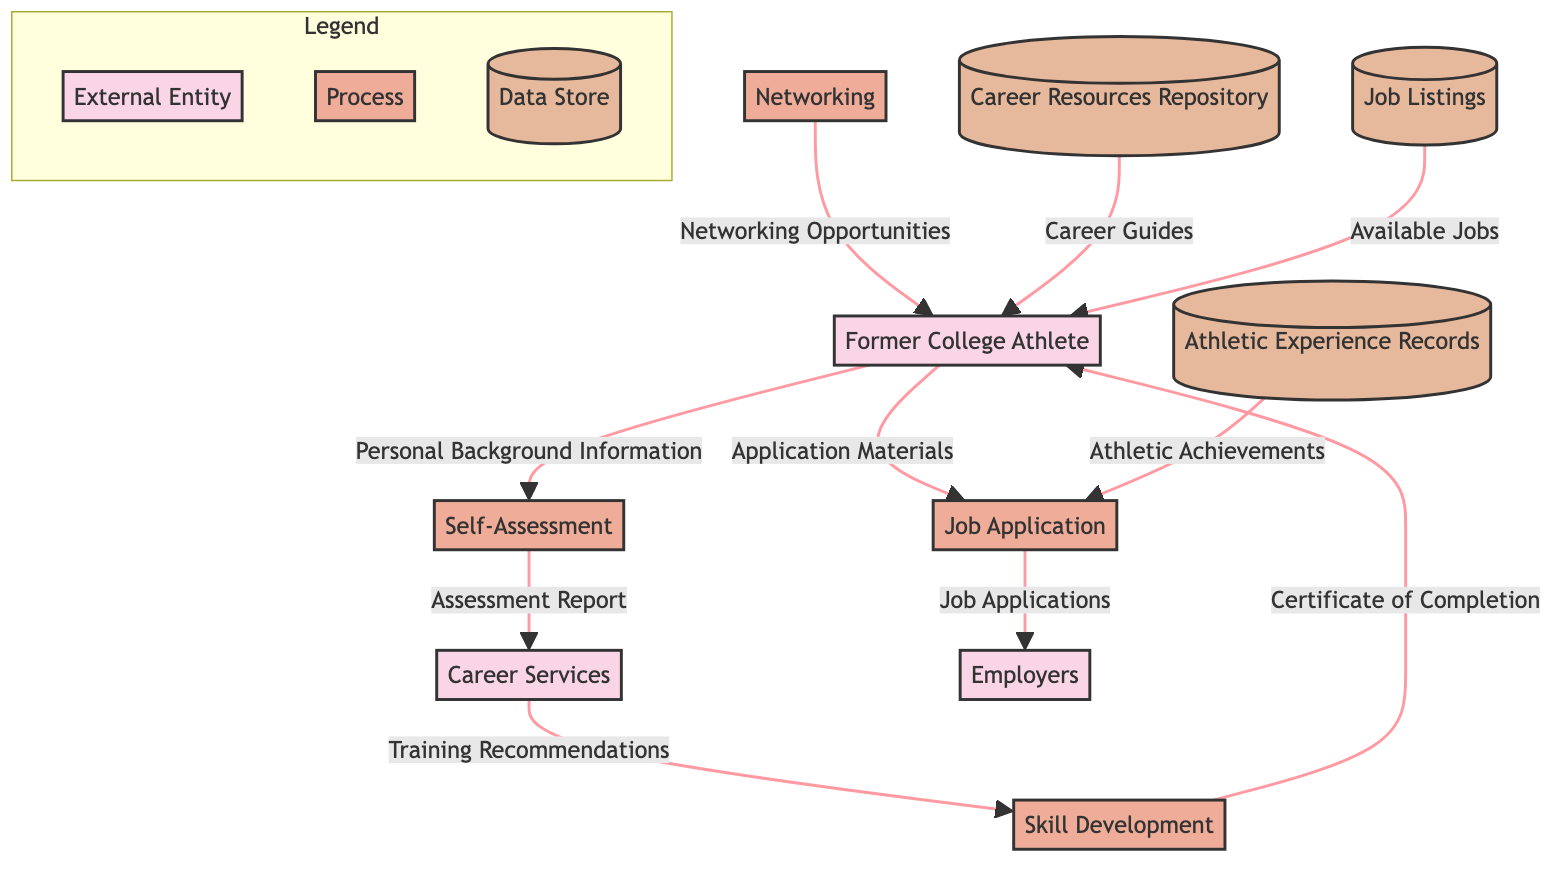What is the first process in the diagram? The first process listed in the processes section of the diagram is "Self-Assessment." This is determined by looking at the order of processes presented, starting with the top.
Answer: Self-Assessment How many external entities are present in the diagram? The diagram shows three external entities: Former College Athlete, Career Services, and Employers. Counting these nodes gives the total number of external entities.
Answer: 3 What data flows from Career Services to Skill Development? The data flowing from Career Services to Skill Development is "Training Recommendations." This is indicated by the arrow connecting these two nodes in the diagram.
Answer: Training Recommendations Which datastore provides career guides to the Former College Athlete? The "Career Resources Repository" provides career guides to the Former College Athlete, as indicated by the data flow that connects the repository to the athlete.
Answer: Career Resources Repository How many processes lead to the Former College Athlete? There are three processes that lead to the Former College Athlete: Skill Development, Networking, and Job Application. By examining the arrows pointing towards the athlete's node, we can confirm this count.
Answer: 3 What is the final process in the diagram before applications are sent to employers? The final process before applications are sent to employers is "Job Application." It's the last step before the data flow to Employers, as seen at the bottom of the diagram.
Answer: Job Application Which data store is linked to the process of Resume Preparation? "Athletic Experience Records" is linked to the process of Resume Preparation. Although Resume Preparation is not explicitly diagrammed as a node, the flow indicates that this store contributes to application materials.
Answer: Athletic Experience Records What type of data does the “Job Listings” datastore provide to the Former College Athlete? The "Job Listings" datastore provides "Available Jobs" to the Former College Athlete, as indicated by the direct connection between these two nodes.
Answer: Available Jobs Which process follows the Self-Assessment process? The process that follows the Self-Assessment process is "Career Services." This can be identified by the arrow that leads from Self-Assessment to Career Services in the diagram.
Answer: Career Services 